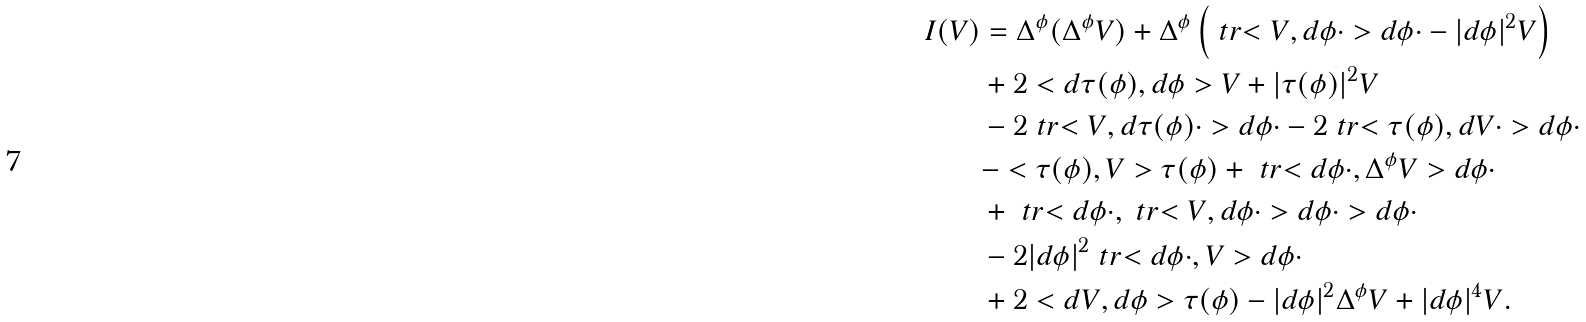Convert formula to latex. <formula><loc_0><loc_0><loc_500><loc_500>I ( V ) & = \Delta ^ { \phi } ( \Delta ^ { \phi } V ) + \Delta ^ { \phi } \left ( \ t r { < V , d \phi \cdot > d \phi \cdot } - | d \phi | ^ { 2 } V \right ) \\ & + 2 < d \tau ( \phi ) , d \phi > V + | \tau ( \phi ) | ^ { 2 } V \\ & - 2 \ t r { < V , d \tau ( \phi ) \cdot > d \phi \cdot } - 2 \ t r { < \tau ( \phi ) , d V \cdot > d \phi \cdot } \\ & - < \tau ( \phi ) , V > \tau ( \phi ) + \ t r { < d \phi \cdot , \Delta ^ { \phi } V > d \phi \cdot } \\ & + \ t r { < d \phi \cdot , \ t r { < V , d \phi \cdot > d \phi \cdot } > d \phi \cdot } \\ & - 2 | d \phi | ^ { 2 } \ t r { < d \phi \cdot , V > d \phi \cdot } \\ & + 2 < d V , d \phi > \tau ( \phi ) - | d \phi | ^ { 2 } \Delta ^ { \phi } V + | d \phi | ^ { 4 } V .</formula> 